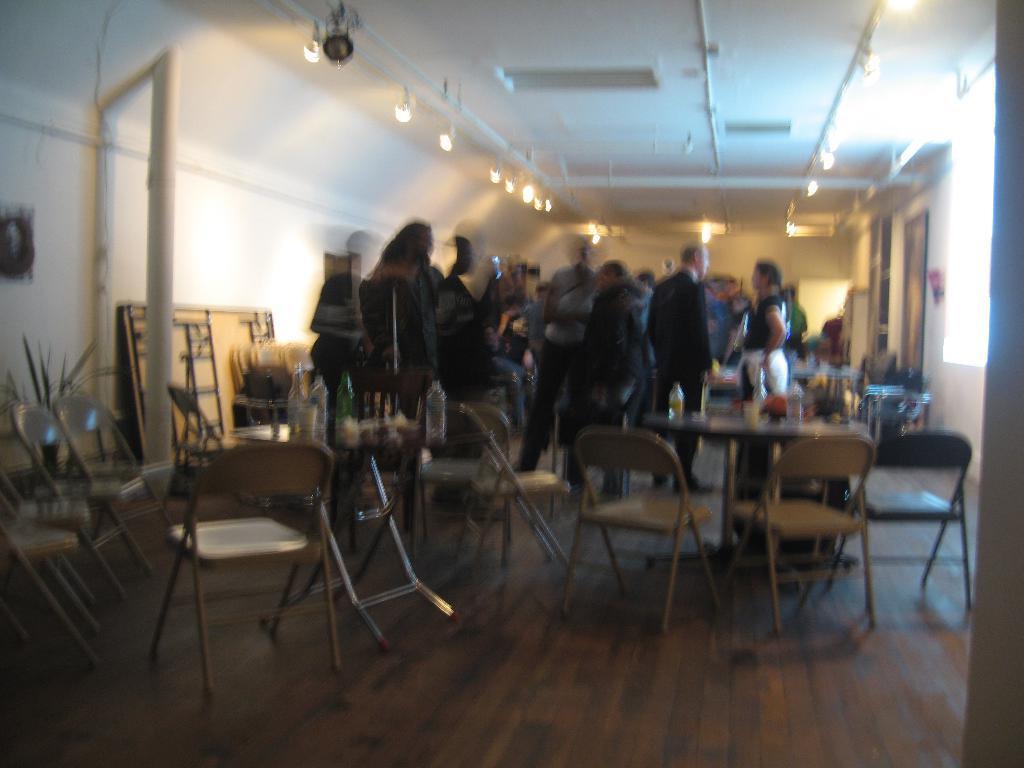How would you summarize this image in a sentence or two? In this image, there is a brown color floor, there are some tables and there are some chairs, there are some bottles kept on the tables, there are some people standing, at the top there are some lights and there is a roof. 